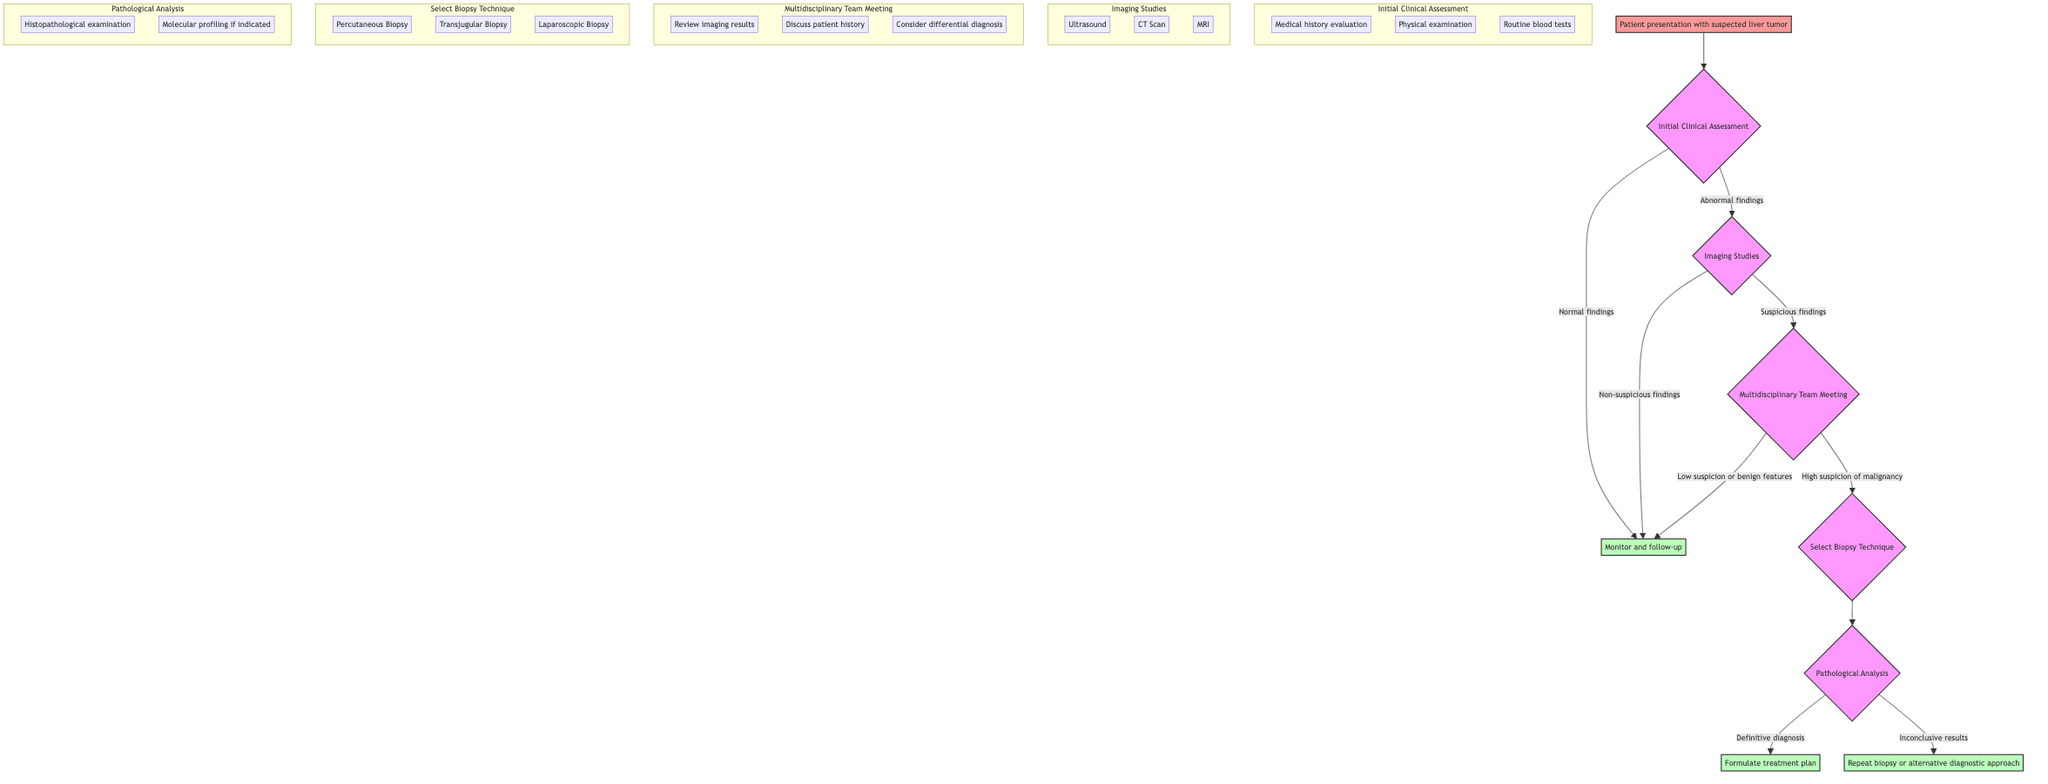What is the starting point of the clinical pathway? According to the diagram, the starting point is "Patient presentation with suspected liver tumor."
Answer: Patient presentation with suspected liver tumor How many decision points are present in the pathway? By counting the nodes labeled as decision points, there are five: Initial Clinical Assessment, Imaging Studies, Multidisciplinary Team Meeting, Select Biopsy Technique, and Pathological Analysis.
Answer: 5 What action is taken after "High suspicion of malignancy"? Following "High suspicion of malignancy," the next action is "Select Biopsy Technique."
Answer: Select Biopsy Technique What are the criteria listed under "Select Biopsy Technique"? The criteria listed under "Select Biopsy Technique" are "Percutaneous Biopsy," "Transjugular Biopsy," and "Laparoscopic Biopsy."
Answer: Percutaneous Biopsy, Transjugular Biopsy, Laparoscopic Biopsy What happens if the results are inconclusive during Pathological Analysis? If the results are inconclusive, the suggested action is to "Repeat biopsy or alternative diagnostic approach."
Answer: Repeat biopsy or alternative diagnostic approach What is the link from "Monitor and follow-up" after "Normal findings"? The link from "Monitor and follow-up" after "Normal findings" terminates in the same "Monitor and follow-up" node, indicating that the patient will continue to be monitored.
Answer: Monitor and follow-up In the "Multidisciplinary Team Meeting," what is one of the criteria evaluated? One of the criteria in the "Multidisciplinary Team Meeting" is "Review imaging results."
Answer: Review imaging results What are the end points in this clinical pathway? The end points listed in the pathway are "Formulate treatment plan based on biopsy results" and "Monitor and follow-up for non-malignant findings or inconclusive results."
Answer: Formulate treatment plan based on biopsy results, Monitor and follow-up for non-malignant findings or inconclusive results 